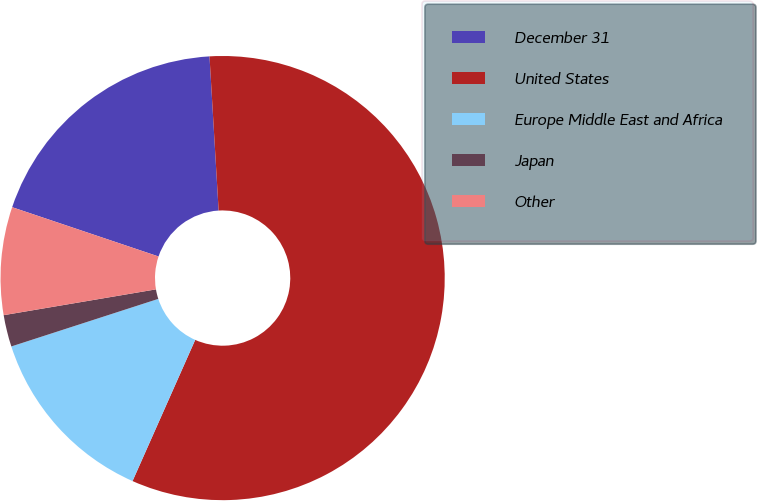<chart> <loc_0><loc_0><loc_500><loc_500><pie_chart><fcel>December 31<fcel>United States<fcel>Europe Middle East and Africa<fcel>Japan<fcel>Other<nl><fcel>18.89%<fcel>57.59%<fcel>13.37%<fcel>2.31%<fcel>7.84%<nl></chart> 